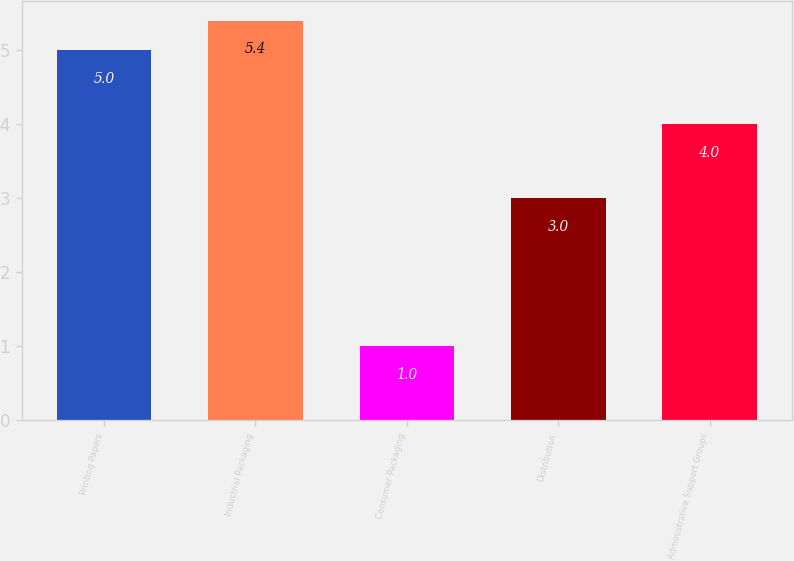Convert chart to OTSL. <chart><loc_0><loc_0><loc_500><loc_500><bar_chart><fcel>Printing Papers<fcel>Industrial Packaging<fcel>Consumer Packaging<fcel>Distribution<fcel>Administrative Support Groups<nl><fcel>5<fcel>5.4<fcel>1<fcel>3<fcel>4<nl></chart> 